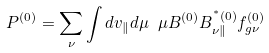Convert formula to latex. <formula><loc_0><loc_0><loc_500><loc_500>P ^ { ( 0 ) } = \sum _ { \nu } \int d v _ { \| } d \mu \ { \mu } B ^ { ( 0 ) } B ^ { ^ { * } { ( 0 ) } } _ { \nu \| } f ^ { ( 0 ) } _ { g \nu }</formula> 